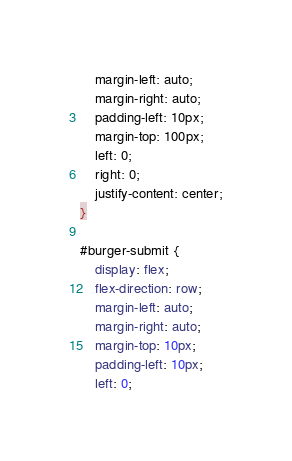<code> <loc_0><loc_0><loc_500><loc_500><_CSS_>    margin-left: auto;
    margin-right: auto;
    padding-left: 10px;
    margin-top: 100px;
    left: 0;
    right: 0;
    justify-content: center;
}

#burger-submit {
    display: flex;
    flex-direction: row;
    margin-left: auto;
    margin-right: auto;
    margin-top: 10px;
    padding-left: 10px;
    left: 0;</code> 